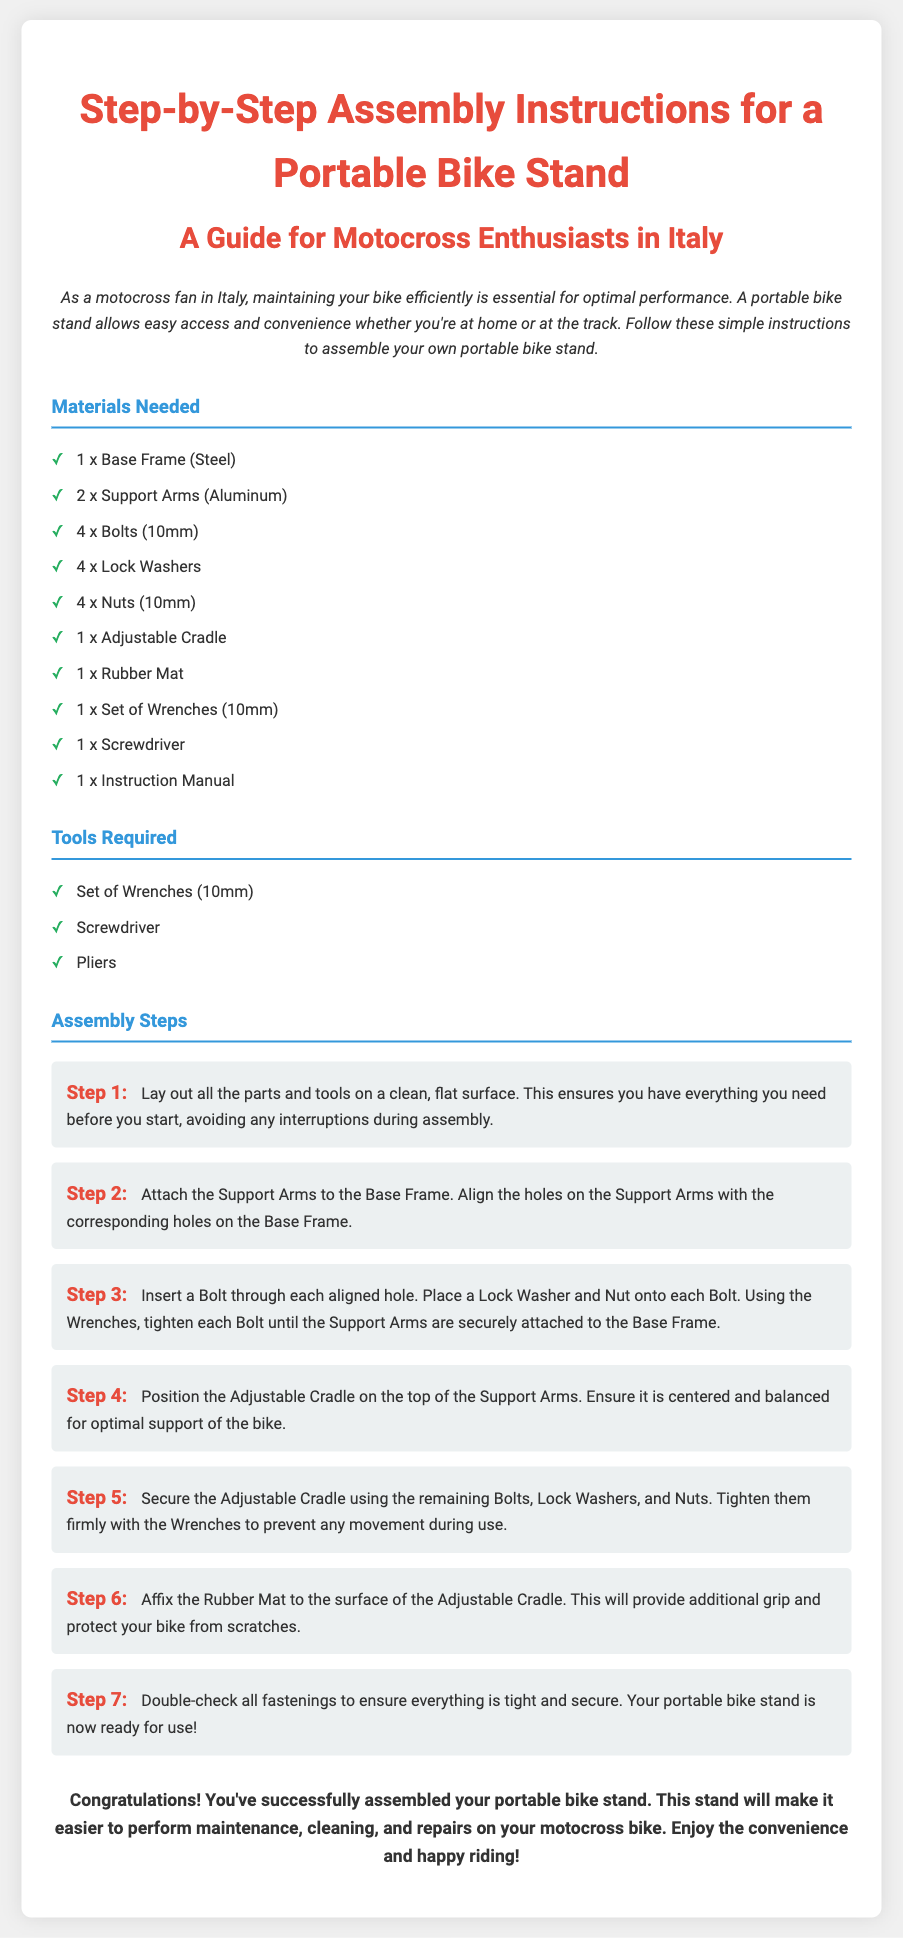What is the title of the document? The title of the document is presented at the top of the rendered content as the main header.
Answer: Step-by-Step Assembly Instructions for a Portable Bike Stand How many Support Arms are needed? The number of Support Arms is specified in the list of materials needed.
Answer: 2 What material is the Base Frame made of? The material of the Base Frame is listed in the materials section.
Answer: Steel What step involves inserting the Bolts? The step that includes inserting the Bolts is mentioned in the assembly steps.
Answer: Step 3 What should be affixed to the Adjustable Cradle? This detail is found in the assembly steps, specifying what additional component is to be added.
Answer: Rubber Mat How many total steps are there in the assembly instructions? By counting the numbered steps provided, the total can be derived.
Answer: 7 Which tool is specifically mentioned as not being needed in the "Tools Required" section? The tools required section lists multiple tools, indicating which ones are needed.
Answer: Pliers Why is the Rubber Mat important for the Adjustable Cradle? This significance is explained in the context of protecting the bike and providing grip.
Answer: Additional grip and protect bike from scratches What is the recommended action to ensure stability after assembly? This action is a part of the last step in the assembly instructions.
Answer: Double-check all fastenings 